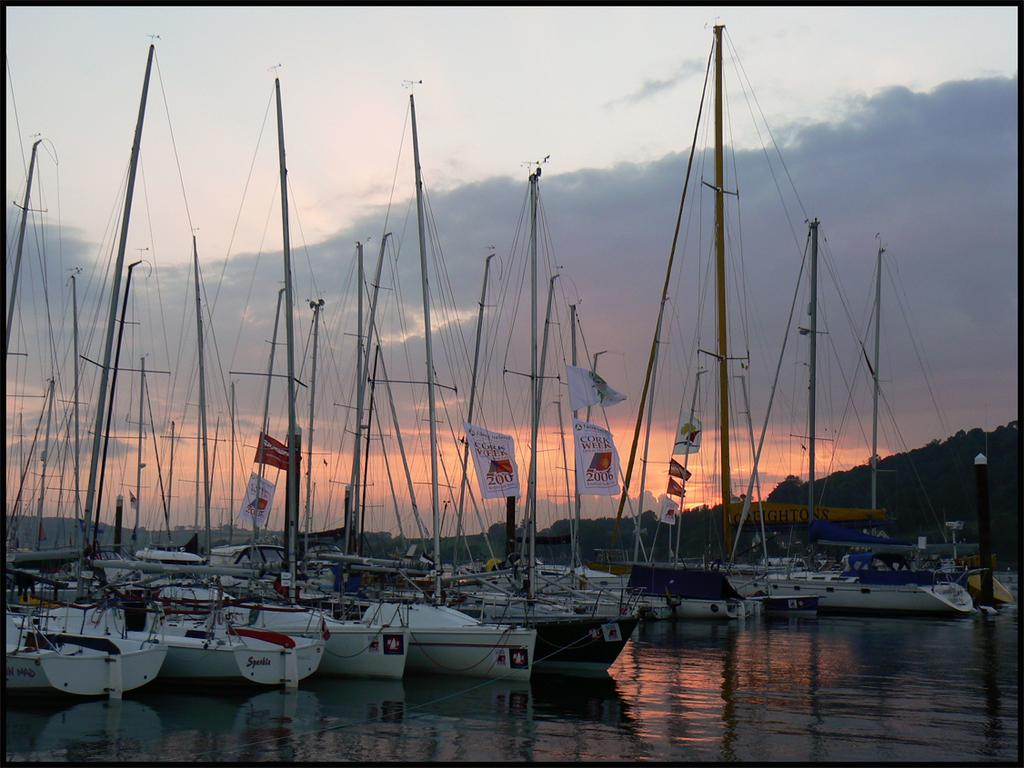<image>
Render a clear and concise summary of the photo. Boats parked on the waters with one whose sail says 2006 on it. 